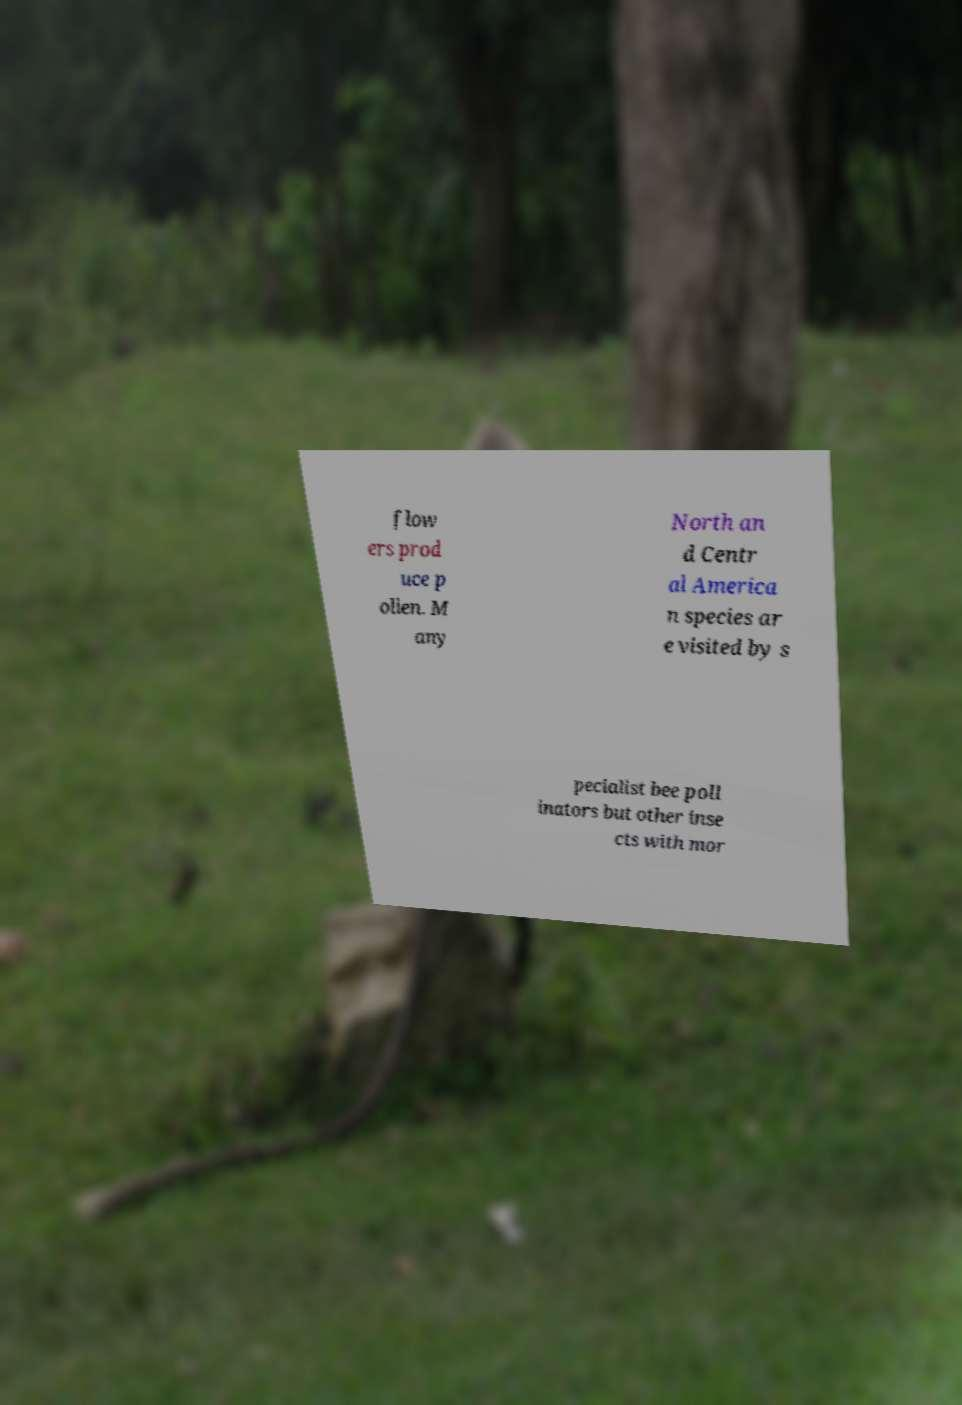Please identify and transcribe the text found in this image. flow ers prod uce p ollen. M any North an d Centr al America n species ar e visited by s pecialist bee poll inators but other inse cts with mor 